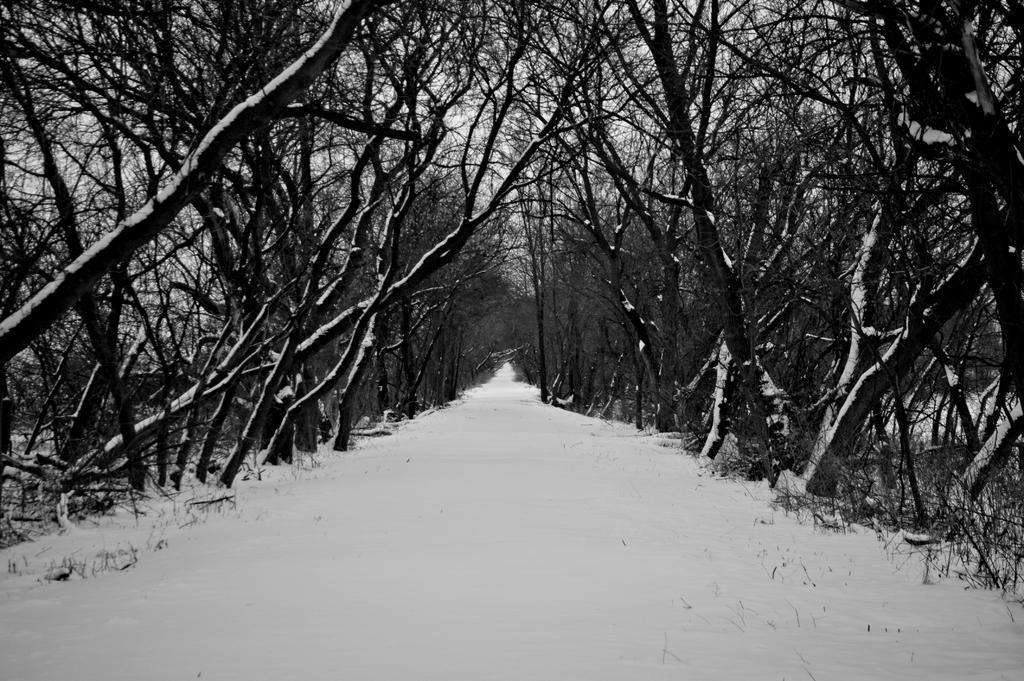Describe this image in one or two sentences. In this image I can see the path and white colored snow on the path. I can see few trees which are black in color on both sides of the path and some snow on the trees. In the background I can see the sky. 